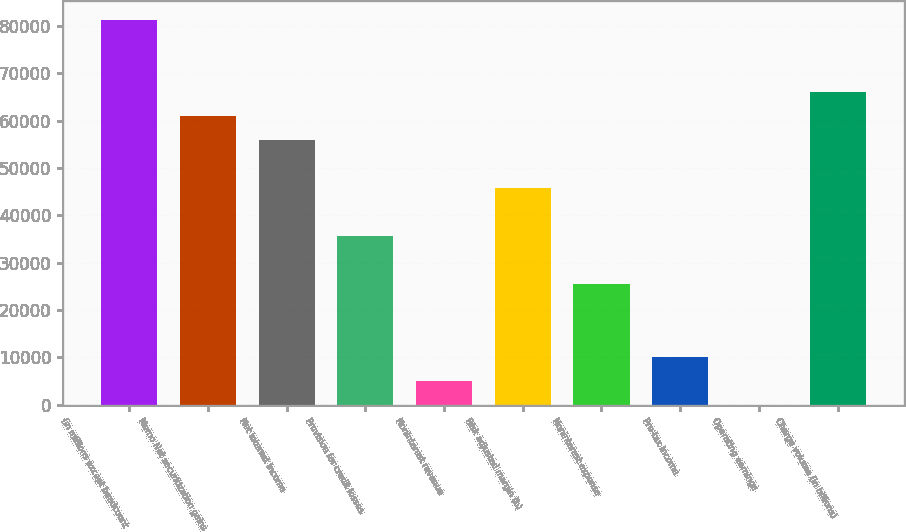Convert chart. <chart><loc_0><loc_0><loc_500><loc_500><bar_chart><fcel>(in millions except headcount<fcel>Memo Net securitization gains<fcel>Net interest income<fcel>Provision for credit losses<fcel>Noninterest revenue<fcel>Risk adjusted margin (b)<fcel>Noninterest expense<fcel>Pre-tax income<fcel>Operating earnings<fcel>Charge volume (in billions)<nl><fcel>81315.9<fcel>60987.3<fcel>55905.1<fcel>35576.5<fcel>5083.52<fcel>45740.8<fcel>25412.2<fcel>10165.7<fcel>1.36<fcel>66069.4<nl></chart> 